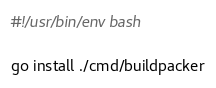<code> <loc_0><loc_0><loc_500><loc_500><_Bash_>#!/usr/bin/env bash

go install ./cmd/buildpacker
</code> 